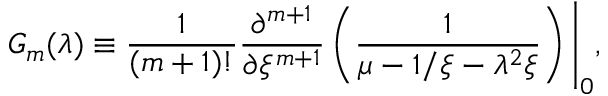<formula> <loc_0><loc_0><loc_500><loc_500>G _ { m } ( \lambda ) \equiv \frac { 1 } { ( m + 1 ) ! } \frac { \partial ^ { m + 1 } } { \partial { \xi ^ { m + 1 } } } \left ( \frac { 1 } { \mu - 1 / \xi - \lambda ^ { 2 } \xi } \right ) \Big | _ { 0 } ,</formula> 